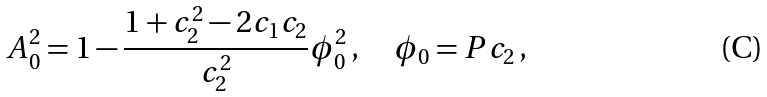Convert formula to latex. <formula><loc_0><loc_0><loc_500><loc_500>A _ { 0 } ^ { 2 } = 1 - \frac { 1 + c _ { 2 } ^ { 2 } - 2 c _ { 1 } c _ { 2 } } { c _ { 2 } ^ { 2 } } \phi _ { 0 } ^ { 2 } \, , \quad \phi _ { 0 } = P c _ { 2 } \, ,</formula> 